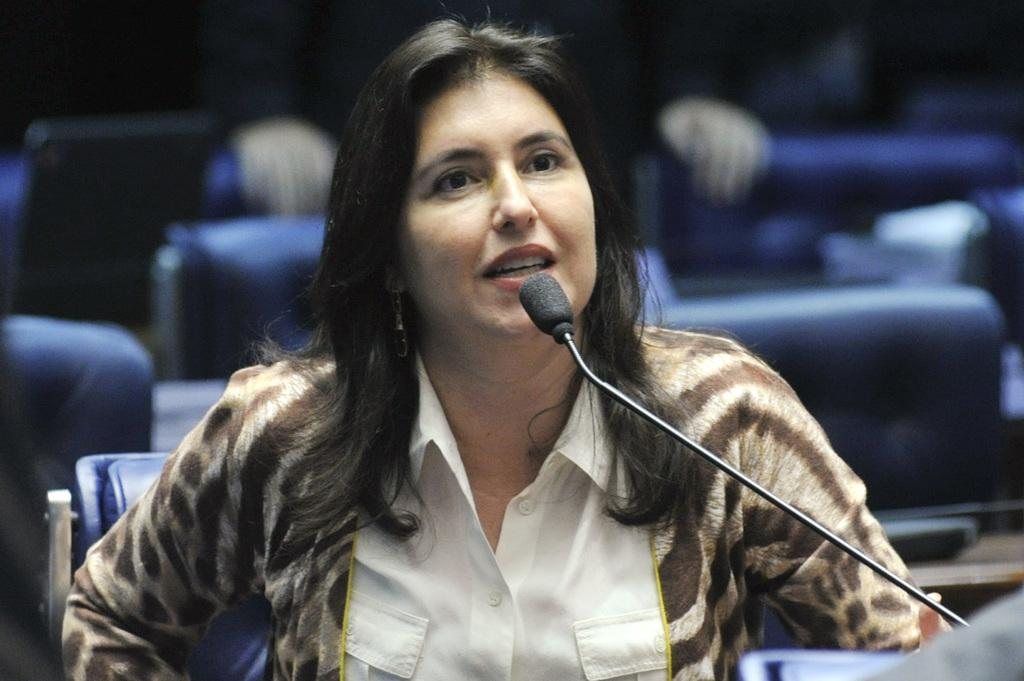What is the lady in the image doing? The lady is sitting and talking in the image. What object is placed in front of the lady? There is a microphone placed before the lady. What can be seen in the background of the image? There are chairs in the background of the image. Can you see the lady biting into a cherry in the image? No, there is no cherry or any indication of the lady biting into one in the image. 